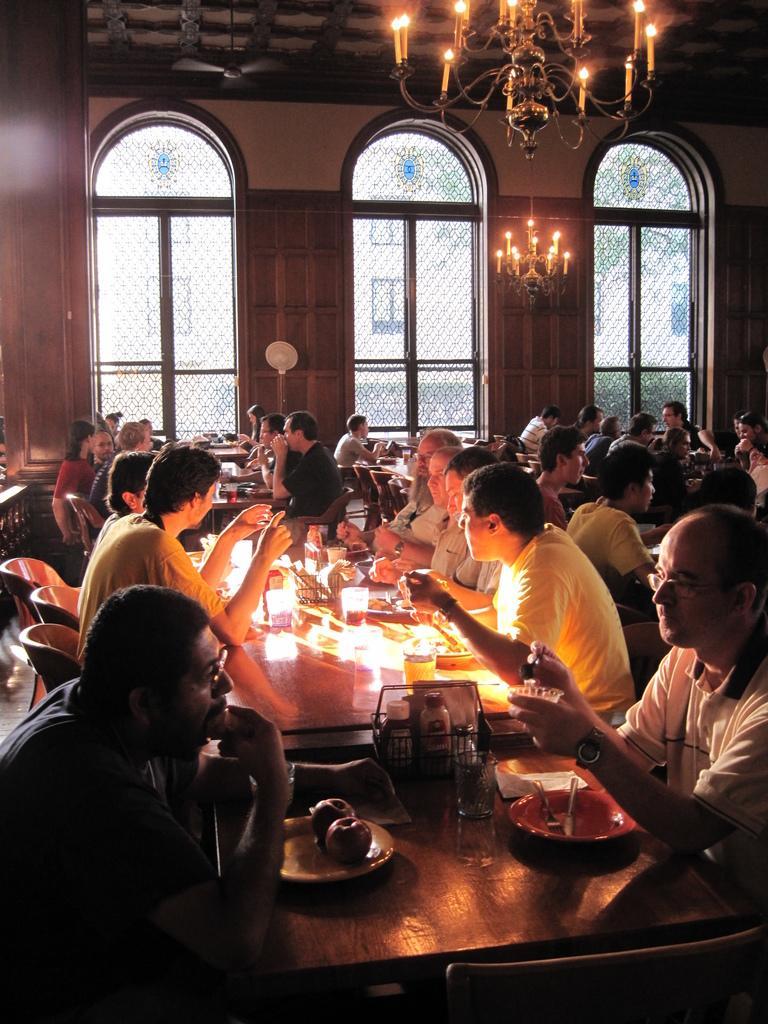Describe this image in one or two sentences. There is a group of people who are sitting on a chair and they are having a food. Here we can see a glass window. This is a roof with lightning arrangement. 